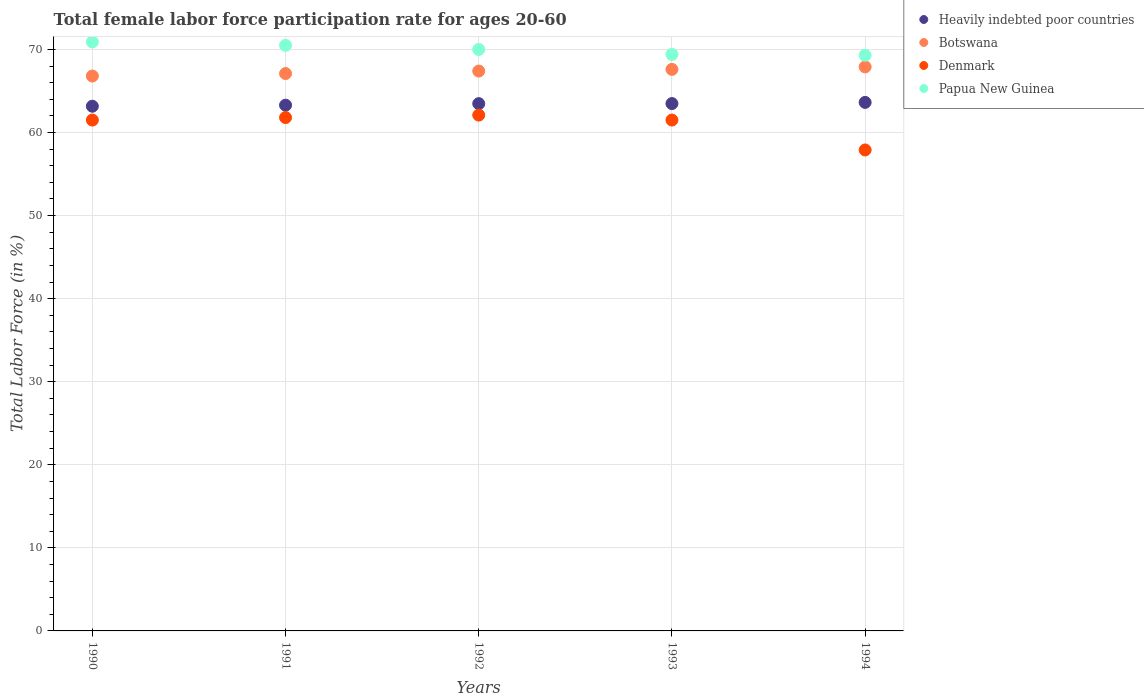How many different coloured dotlines are there?
Provide a succinct answer. 4. What is the female labor force participation rate in Denmark in 1993?
Your response must be concise. 61.5. Across all years, what is the maximum female labor force participation rate in Heavily indebted poor countries?
Provide a short and direct response. 63.63. Across all years, what is the minimum female labor force participation rate in Botswana?
Offer a terse response. 66.8. What is the total female labor force participation rate in Denmark in the graph?
Your answer should be compact. 304.8. What is the difference between the female labor force participation rate in Heavily indebted poor countries in 1990 and that in 1991?
Ensure brevity in your answer.  -0.13. What is the difference between the female labor force participation rate in Papua New Guinea in 1992 and the female labor force participation rate in Botswana in 1990?
Your answer should be very brief. 3.2. What is the average female labor force participation rate in Heavily indebted poor countries per year?
Make the answer very short. 63.41. In the year 1991, what is the difference between the female labor force participation rate in Heavily indebted poor countries and female labor force participation rate in Denmark?
Keep it short and to the point. 1.49. In how many years, is the female labor force participation rate in Papua New Guinea greater than 60 %?
Your answer should be very brief. 5. What is the ratio of the female labor force participation rate in Heavily indebted poor countries in 1990 to that in 1992?
Give a very brief answer. 1. Is the female labor force participation rate in Denmark in 1990 less than that in 1991?
Your answer should be compact. Yes. Is the difference between the female labor force participation rate in Heavily indebted poor countries in 1991 and 1994 greater than the difference between the female labor force participation rate in Denmark in 1991 and 1994?
Offer a terse response. No. What is the difference between the highest and the second highest female labor force participation rate in Papua New Guinea?
Provide a short and direct response. 0.4. What is the difference between the highest and the lowest female labor force participation rate in Heavily indebted poor countries?
Offer a very short reply. 0.46. In how many years, is the female labor force participation rate in Botswana greater than the average female labor force participation rate in Botswana taken over all years?
Make the answer very short. 3. Is the sum of the female labor force participation rate in Papua New Guinea in 1993 and 1994 greater than the maximum female labor force participation rate in Heavily indebted poor countries across all years?
Ensure brevity in your answer.  Yes. Is it the case that in every year, the sum of the female labor force participation rate in Botswana and female labor force participation rate in Heavily indebted poor countries  is greater than the sum of female labor force participation rate in Papua New Guinea and female labor force participation rate in Denmark?
Offer a very short reply. Yes. Is it the case that in every year, the sum of the female labor force participation rate in Botswana and female labor force participation rate in Denmark  is greater than the female labor force participation rate in Papua New Guinea?
Offer a very short reply. Yes. Is the female labor force participation rate in Heavily indebted poor countries strictly less than the female labor force participation rate in Botswana over the years?
Your answer should be compact. Yes. How many years are there in the graph?
Keep it short and to the point. 5. What is the difference between two consecutive major ticks on the Y-axis?
Give a very brief answer. 10. Does the graph contain grids?
Offer a terse response. Yes. What is the title of the graph?
Provide a short and direct response. Total female labor force participation rate for ages 20-60. Does "Latin America(all income levels)" appear as one of the legend labels in the graph?
Provide a succinct answer. No. What is the label or title of the X-axis?
Provide a short and direct response. Years. What is the label or title of the Y-axis?
Make the answer very short. Total Labor Force (in %). What is the Total Labor Force (in %) of Heavily indebted poor countries in 1990?
Give a very brief answer. 63.16. What is the Total Labor Force (in %) of Botswana in 1990?
Your response must be concise. 66.8. What is the Total Labor Force (in %) of Denmark in 1990?
Keep it short and to the point. 61.5. What is the Total Labor Force (in %) of Papua New Guinea in 1990?
Provide a succinct answer. 70.9. What is the Total Labor Force (in %) of Heavily indebted poor countries in 1991?
Provide a short and direct response. 63.29. What is the Total Labor Force (in %) of Botswana in 1991?
Give a very brief answer. 67.1. What is the Total Labor Force (in %) in Denmark in 1991?
Provide a short and direct response. 61.8. What is the Total Labor Force (in %) in Papua New Guinea in 1991?
Provide a short and direct response. 70.5. What is the Total Labor Force (in %) in Heavily indebted poor countries in 1992?
Your response must be concise. 63.48. What is the Total Labor Force (in %) in Botswana in 1992?
Keep it short and to the point. 67.4. What is the Total Labor Force (in %) of Denmark in 1992?
Your answer should be compact. 62.1. What is the Total Labor Force (in %) in Papua New Guinea in 1992?
Provide a short and direct response. 70. What is the Total Labor Force (in %) of Heavily indebted poor countries in 1993?
Provide a succinct answer. 63.49. What is the Total Labor Force (in %) of Botswana in 1993?
Keep it short and to the point. 67.6. What is the Total Labor Force (in %) in Denmark in 1993?
Give a very brief answer. 61.5. What is the Total Labor Force (in %) in Papua New Guinea in 1993?
Give a very brief answer. 69.4. What is the Total Labor Force (in %) in Heavily indebted poor countries in 1994?
Keep it short and to the point. 63.63. What is the Total Labor Force (in %) of Botswana in 1994?
Keep it short and to the point. 67.9. What is the Total Labor Force (in %) in Denmark in 1994?
Offer a terse response. 57.9. What is the Total Labor Force (in %) in Papua New Guinea in 1994?
Provide a succinct answer. 69.3. Across all years, what is the maximum Total Labor Force (in %) of Heavily indebted poor countries?
Your answer should be compact. 63.63. Across all years, what is the maximum Total Labor Force (in %) in Botswana?
Keep it short and to the point. 67.9. Across all years, what is the maximum Total Labor Force (in %) of Denmark?
Keep it short and to the point. 62.1. Across all years, what is the maximum Total Labor Force (in %) of Papua New Guinea?
Make the answer very short. 70.9. Across all years, what is the minimum Total Labor Force (in %) of Heavily indebted poor countries?
Ensure brevity in your answer.  63.16. Across all years, what is the minimum Total Labor Force (in %) in Botswana?
Offer a terse response. 66.8. Across all years, what is the minimum Total Labor Force (in %) of Denmark?
Give a very brief answer. 57.9. Across all years, what is the minimum Total Labor Force (in %) of Papua New Guinea?
Keep it short and to the point. 69.3. What is the total Total Labor Force (in %) of Heavily indebted poor countries in the graph?
Give a very brief answer. 317.04. What is the total Total Labor Force (in %) of Botswana in the graph?
Ensure brevity in your answer.  336.8. What is the total Total Labor Force (in %) in Denmark in the graph?
Make the answer very short. 304.8. What is the total Total Labor Force (in %) of Papua New Guinea in the graph?
Make the answer very short. 350.1. What is the difference between the Total Labor Force (in %) of Heavily indebted poor countries in 1990 and that in 1991?
Your answer should be very brief. -0.13. What is the difference between the Total Labor Force (in %) in Denmark in 1990 and that in 1991?
Your answer should be very brief. -0.3. What is the difference between the Total Labor Force (in %) of Heavily indebted poor countries in 1990 and that in 1992?
Offer a terse response. -0.31. What is the difference between the Total Labor Force (in %) in Botswana in 1990 and that in 1992?
Provide a short and direct response. -0.6. What is the difference between the Total Labor Force (in %) of Denmark in 1990 and that in 1992?
Keep it short and to the point. -0.6. What is the difference between the Total Labor Force (in %) of Papua New Guinea in 1990 and that in 1992?
Make the answer very short. 0.9. What is the difference between the Total Labor Force (in %) in Heavily indebted poor countries in 1990 and that in 1993?
Your response must be concise. -0.32. What is the difference between the Total Labor Force (in %) of Papua New Guinea in 1990 and that in 1993?
Keep it short and to the point. 1.5. What is the difference between the Total Labor Force (in %) of Heavily indebted poor countries in 1990 and that in 1994?
Provide a succinct answer. -0.46. What is the difference between the Total Labor Force (in %) of Denmark in 1990 and that in 1994?
Your answer should be very brief. 3.6. What is the difference between the Total Labor Force (in %) in Heavily indebted poor countries in 1991 and that in 1992?
Your response must be concise. -0.19. What is the difference between the Total Labor Force (in %) in Botswana in 1991 and that in 1992?
Provide a short and direct response. -0.3. What is the difference between the Total Labor Force (in %) in Heavily indebted poor countries in 1991 and that in 1993?
Make the answer very short. -0.19. What is the difference between the Total Labor Force (in %) of Botswana in 1991 and that in 1993?
Offer a very short reply. -0.5. What is the difference between the Total Labor Force (in %) in Denmark in 1991 and that in 1993?
Provide a succinct answer. 0.3. What is the difference between the Total Labor Force (in %) of Papua New Guinea in 1991 and that in 1993?
Offer a terse response. 1.1. What is the difference between the Total Labor Force (in %) of Heavily indebted poor countries in 1991 and that in 1994?
Offer a terse response. -0.33. What is the difference between the Total Labor Force (in %) of Botswana in 1991 and that in 1994?
Keep it short and to the point. -0.8. What is the difference between the Total Labor Force (in %) of Denmark in 1991 and that in 1994?
Offer a very short reply. 3.9. What is the difference between the Total Labor Force (in %) of Heavily indebted poor countries in 1992 and that in 1993?
Your answer should be compact. -0.01. What is the difference between the Total Labor Force (in %) of Denmark in 1992 and that in 1993?
Give a very brief answer. 0.6. What is the difference between the Total Labor Force (in %) of Heavily indebted poor countries in 1992 and that in 1994?
Ensure brevity in your answer.  -0.15. What is the difference between the Total Labor Force (in %) in Denmark in 1992 and that in 1994?
Offer a very short reply. 4.2. What is the difference between the Total Labor Force (in %) in Papua New Guinea in 1992 and that in 1994?
Make the answer very short. 0.7. What is the difference between the Total Labor Force (in %) in Heavily indebted poor countries in 1993 and that in 1994?
Give a very brief answer. -0.14. What is the difference between the Total Labor Force (in %) of Botswana in 1993 and that in 1994?
Provide a succinct answer. -0.3. What is the difference between the Total Labor Force (in %) in Papua New Guinea in 1993 and that in 1994?
Provide a short and direct response. 0.1. What is the difference between the Total Labor Force (in %) of Heavily indebted poor countries in 1990 and the Total Labor Force (in %) of Botswana in 1991?
Your answer should be compact. -3.94. What is the difference between the Total Labor Force (in %) in Heavily indebted poor countries in 1990 and the Total Labor Force (in %) in Denmark in 1991?
Offer a very short reply. 1.36. What is the difference between the Total Labor Force (in %) in Heavily indebted poor countries in 1990 and the Total Labor Force (in %) in Papua New Guinea in 1991?
Ensure brevity in your answer.  -7.34. What is the difference between the Total Labor Force (in %) in Botswana in 1990 and the Total Labor Force (in %) in Papua New Guinea in 1991?
Your answer should be compact. -3.7. What is the difference between the Total Labor Force (in %) of Heavily indebted poor countries in 1990 and the Total Labor Force (in %) of Botswana in 1992?
Your answer should be very brief. -4.24. What is the difference between the Total Labor Force (in %) in Heavily indebted poor countries in 1990 and the Total Labor Force (in %) in Denmark in 1992?
Your response must be concise. 1.06. What is the difference between the Total Labor Force (in %) of Heavily indebted poor countries in 1990 and the Total Labor Force (in %) of Papua New Guinea in 1992?
Offer a terse response. -6.84. What is the difference between the Total Labor Force (in %) of Botswana in 1990 and the Total Labor Force (in %) of Denmark in 1992?
Your answer should be compact. 4.7. What is the difference between the Total Labor Force (in %) of Heavily indebted poor countries in 1990 and the Total Labor Force (in %) of Botswana in 1993?
Ensure brevity in your answer.  -4.44. What is the difference between the Total Labor Force (in %) in Heavily indebted poor countries in 1990 and the Total Labor Force (in %) in Denmark in 1993?
Your answer should be compact. 1.66. What is the difference between the Total Labor Force (in %) in Heavily indebted poor countries in 1990 and the Total Labor Force (in %) in Papua New Guinea in 1993?
Provide a short and direct response. -6.24. What is the difference between the Total Labor Force (in %) in Heavily indebted poor countries in 1990 and the Total Labor Force (in %) in Botswana in 1994?
Offer a terse response. -4.74. What is the difference between the Total Labor Force (in %) of Heavily indebted poor countries in 1990 and the Total Labor Force (in %) of Denmark in 1994?
Give a very brief answer. 5.26. What is the difference between the Total Labor Force (in %) of Heavily indebted poor countries in 1990 and the Total Labor Force (in %) of Papua New Guinea in 1994?
Ensure brevity in your answer.  -6.14. What is the difference between the Total Labor Force (in %) in Botswana in 1990 and the Total Labor Force (in %) in Denmark in 1994?
Your answer should be very brief. 8.9. What is the difference between the Total Labor Force (in %) of Heavily indebted poor countries in 1991 and the Total Labor Force (in %) of Botswana in 1992?
Give a very brief answer. -4.11. What is the difference between the Total Labor Force (in %) in Heavily indebted poor countries in 1991 and the Total Labor Force (in %) in Denmark in 1992?
Offer a very short reply. 1.19. What is the difference between the Total Labor Force (in %) of Heavily indebted poor countries in 1991 and the Total Labor Force (in %) of Papua New Guinea in 1992?
Make the answer very short. -6.71. What is the difference between the Total Labor Force (in %) in Denmark in 1991 and the Total Labor Force (in %) in Papua New Guinea in 1992?
Offer a very short reply. -8.2. What is the difference between the Total Labor Force (in %) of Heavily indebted poor countries in 1991 and the Total Labor Force (in %) of Botswana in 1993?
Make the answer very short. -4.31. What is the difference between the Total Labor Force (in %) of Heavily indebted poor countries in 1991 and the Total Labor Force (in %) of Denmark in 1993?
Provide a short and direct response. 1.79. What is the difference between the Total Labor Force (in %) in Heavily indebted poor countries in 1991 and the Total Labor Force (in %) in Papua New Guinea in 1993?
Keep it short and to the point. -6.11. What is the difference between the Total Labor Force (in %) of Botswana in 1991 and the Total Labor Force (in %) of Denmark in 1993?
Provide a succinct answer. 5.6. What is the difference between the Total Labor Force (in %) in Botswana in 1991 and the Total Labor Force (in %) in Papua New Guinea in 1993?
Offer a very short reply. -2.3. What is the difference between the Total Labor Force (in %) of Heavily indebted poor countries in 1991 and the Total Labor Force (in %) of Botswana in 1994?
Make the answer very short. -4.61. What is the difference between the Total Labor Force (in %) in Heavily indebted poor countries in 1991 and the Total Labor Force (in %) in Denmark in 1994?
Offer a very short reply. 5.39. What is the difference between the Total Labor Force (in %) of Heavily indebted poor countries in 1991 and the Total Labor Force (in %) of Papua New Guinea in 1994?
Give a very brief answer. -6.01. What is the difference between the Total Labor Force (in %) of Botswana in 1991 and the Total Labor Force (in %) of Denmark in 1994?
Keep it short and to the point. 9.2. What is the difference between the Total Labor Force (in %) of Botswana in 1991 and the Total Labor Force (in %) of Papua New Guinea in 1994?
Give a very brief answer. -2.2. What is the difference between the Total Labor Force (in %) in Denmark in 1991 and the Total Labor Force (in %) in Papua New Guinea in 1994?
Keep it short and to the point. -7.5. What is the difference between the Total Labor Force (in %) of Heavily indebted poor countries in 1992 and the Total Labor Force (in %) of Botswana in 1993?
Ensure brevity in your answer.  -4.12. What is the difference between the Total Labor Force (in %) of Heavily indebted poor countries in 1992 and the Total Labor Force (in %) of Denmark in 1993?
Your response must be concise. 1.98. What is the difference between the Total Labor Force (in %) of Heavily indebted poor countries in 1992 and the Total Labor Force (in %) of Papua New Guinea in 1993?
Your answer should be compact. -5.92. What is the difference between the Total Labor Force (in %) in Denmark in 1992 and the Total Labor Force (in %) in Papua New Guinea in 1993?
Give a very brief answer. -7.3. What is the difference between the Total Labor Force (in %) in Heavily indebted poor countries in 1992 and the Total Labor Force (in %) in Botswana in 1994?
Offer a very short reply. -4.42. What is the difference between the Total Labor Force (in %) in Heavily indebted poor countries in 1992 and the Total Labor Force (in %) in Denmark in 1994?
Ensure brevity in your answer.  5.58. What is the difference between the Total Labor Force (in %) of Heavily indebted poor countries in 1992 and the Total Labor Force (in %) of Papua New Guinea in 1994?
Offer a terse response. -5.82. What is the difference between the Total Labor Force (in %) of Botswana in 1992 and the Total Labor Force (in %) of Denmark in 1994?
Provide a short and direct response. 9.5. What is the difference between the Total Labor Force (in %) of Botswana in 1992 and the Total Labor Force (in %) of Papua New Guinea in 1994?
Your answer should be compact. -1.9. What is the difference between the Total Labor Force (in %) of Denmark in 1992 and the Total Labor Force (in %) of Papua New Guinea in 1994?
Offer a terse response. -7.2. What is the difference between the Total Labor Force (in %) in Heavily indebted poor countries in 1993 and the Total Labor Force (in %) in Botswana in 1994?
Make the answer very short. -4.41. What is the difference between the Total Labor Force (in %) of Heavily indebted poor countries in 1993 and the Total Labor Force (in %) of Denmark in 1994?
Give a very brief answer. 5.59. What is the difference between the Total Labor Force (in %) of Heavily indebted poor countries in 1993 and the Total Labor Force (in %) of Papua New Guinea in 1994?
Keep it short and to the point. -5.81. What is the average Total Labor Force (in %) of Heavily indebted poor countries per year?
Provide a succinct answer. 63.41. What is the average Total Labor Force (in %) of Botswana per year?
Offer a terse response. 67.36. What is the average Total Labor Force (in %) of Denmark per year?
Offer a very short reply. 60.96. What is the average Total Labor Force (in %) in Papua New Guinea per year?
Provide a short and direct response. 70.02. In the year 1990, what is the difference between the Total Labor Force (in %) in Heavily indebted poor countries and Total Labor Force (in %) in Botswana?
Provide a short and direct response. -3.64. In the year 1990, what is the difference between the Total Labor Force (in %) of Heavily indebted poor countries and Total Labor Force (in %) of Denmark?
Make the answer very short. 1.66. In the year 1990, what is the difference between the Total Labor Force (in %) in Heavily indebted poor countries and Total Labor Force (in %) in Papua New Guinea?
Offer a very short reply. -7.74. In the year 1990, what is the difference between the Total Labor Force (in %) in Denmark and Total Labor Force (in %) in Papua New Guinea?
Provide a succinct answer. -9.4. In the year 1991, what is the difference between the Total Labor Force (in %) of Heavily indebted poor countries and Total Labor Force (in %) of Botswana?
Keep it short and to the point. -3.81. In the year 1991, what is the difference between the Total Labor Force (in %) of Heavily indebted poor countries and Total Labor Force (in %) of Denmark?
Offer a very short reply. 1.49. In the year 1991, what is the difference between the Total Labor Force (in %) in Heavily indebted poor countries and Total Labor Force (in %) in Papua New Guinea?
Ensure brevity in your answer.  -7.21. In the year 1991, what is the difference between the Total Labor Force (in %) of Botswana and Total Labor Force (in %) of Denmark?
Provide a succinct answer. 5.3. In the year 1991, what is the difference between the Total Labor Force (in %) in Denmark and Total Labor Force (in %) in Papua New Guinea?
Give a very brief answer. -8.7. In the year 1992, what is the difference between the Total Labor Force (in %) of Heavily indebted poor countries and Total Labor Force (in %) of Botswana?
Keep it short and to the point. -3.92. In the year 1992, what is the difference between the Total Labor Force (in %) of Heavily indebted poor countries and Total Labor Force (in %) of Denmark?
Ensure brevity in your answer.  1.38. In the year 1992, what is the difference between the Total Labor Force (in %) in Heavily indebted poor countries and Total Labor Force (in %) in Papua New Guinea?
Your answer should be very brief. -6.52. In the year 1992, what is the difference between the Total Labor Force (in %) in Botswana and Total Labor Force (in %) in Denmark?
Your response must be concise. 5.3. In the year 1992, what is the difference between the Total Labor Force (in %) in Botswana and Total Labor Force (in %) in Papua New Guinea?
Provide a succinct answer. -2.6. In the year 1992, what is the difference between the Total Labor Force (in %) in Denmark and Total Labor Force (in %) in Papua New Guinea?
Give a very brief answer. -7.9. In the year 1993, what is the difference between the Total Labor Force (in %) of Heavily indebted poor countries and Total Labor Force (in %) of Botswana?
Give a very brief answer. -4.11. In the year 1993, what is the difference between the Total Labor Force (in %) in Heavily indebted poor countries and Total Labor Force (in %) in Denmark?
Give a very brief answer. 1.99. In the year 1993, what is the difference between the Total Labor Force (in %) in Heavily indebted poor countries and Total Labor Force (in %) in Papua New Guinea?
Give a very brief answer. -5.91. In the year 1994, what is the difference between the Total Labor Force (in %) of Heavily indebted poor countries and Total Labor Force (in %) of Botswana?
Offer a terse response. -4.27. In the year 1994, what is the difference between the Total Labor Force (in %) in Heavily indebted poor countries and Total Labor Force (in %) in Denmark?
Provide a succinct answer. 5.73. In the year 1994, what is the difference between the Total Labor Force (in %) in Heavily indebted poor countries and Total Labor Force (in %) in Papua New Guinea?
Your answer should be very brief. -5.67. In the year 1994, what is the difference between the Total Labor Force (in %) in Botswana and Total Labor Force (in %) in Papua New Guinea?
Make the answer very short. -1.4. In the year 1994, what is the difference between the Total Labor Force (in %) of Denmark and Total Labor Force (in %) of Papua New Guinea?
Provide a succinct answer. -11.4. What is the ratio of the Total Labor Force (in %) of Heavily indebted poor countries in 1990 to that in 1991?
Offer a very short reply. 1. What is the ratio of the Total Labor Force (in %) of Heavily indebted poor countries in 1990 to that in 1992?
Provide a short and direct response. 1. What is the ratio of the Total Labor Force (in %) in Botswana in 1990 to that in 1992?
Keep it short and to the point. 0.99. What is the ratio of the Total Labor Force (in %) in Denmark in 1990 to that in 1992?
Your answer should be compact. 0.99. What is the ratio of the Total Labor Force (in %) in Papua New Guinea in 1990 to that in 1992?
Offer a very short reply. 1.01. What is the ratio of the Total Labor Force (in %) in Heavily indebted poor countries in 1990 to that in 1993?
Offer a terse response. 0.99. What is the ratio of the Total Labor Force (in %) in Botswana in 1990 to that in 1993?
Offer a terse response. 0.99. What is the ratio of the Total Labor Force (in %) of Papua New Guinea in 1990 to that in 1993?
Keep it short and to the point. 1.02. What is the ratio of the Total Labor Force (in %) of Heavily indebted poor countries in 1990 to that in 1994?
Your answer should be compact. 0.99. What is the ratio of the Total Labor Force (in %) of Botswana in 1990 to that in 1994?
Your response must be concise. 0.98. What is the ratio of the Total Labor Force (in %) of Denmark in 1990 to that in 1994?
Provide a short and direct response. 1.06. What is the ratio of the Total Labor Force (in %) of Papua New Guinea in 1990 to that in 1994?
Make the answer very short. 1.02. What is the ratio of the Total Labor Force (in %) in Heavily indebted poor countries in 1991 to that in 1992?
Your answer should be compact. 1. What is the ratio of the Total Labor Force (in %) of Denmark in 1991 to that in 1992?
Offer a terse response. 1. What is the ratio of the Total Labor Force (in %) of Papua New Guinea in 1991 to that in 1992?
Ensure brevity in your answer.  1.01. What is the ratio of the Total Labor Force (in %) of Heavily indebted poor countries in 1991 to that in 1993?
Offer a very short reply. 1. What is the ratio of the Total Labor Force (in %) in Papua New Guinea in 1991 to that in 1993?
Your answer should be very brief. 1.02. What is the ratio of the Total Labor Force (in %) of Botswana in 1991 to that in 1994?
Offer a terse response. 0.99. What is the ratio of the Total Labor Force (in %) in Denmark in 1991 to that in 1994?
Provide a short and direct response. 1.07. What is the ratio of the Total Labor Force (in %) of Papua New Guinea in 1991 to that in 1994?
Provide a short and direct response. 1.02. What is the ratio of the Total Labor Force (in %) in Heavily indebted poor countries in 1992 to that in 1993?
Your answer should be compact. 1. What is the ratio of the Total Labor Force (in %) in Botswana in 1992 to that in 1993?
Keep it short and to the point. 1. What is the ratio of the Total Labor Force (in %) in Denmark in 1992 to that in 1993?
Provide a succinct answer. 1.01. What is the ratio of the Total Labor Force (in %) in Papua New Guinea in 1992 to that in 1993?
Offer a very short reply. 1.01. What is the ratio of the Total Labor Force (in %) in Heavily indebted poor countries in 1992 to that in 1994?
Give a very brief answer. 1. What is the ratio of the Total Labor Force (in %) of Botswana in 1992 to that in 1994?
Offer a terse response. 0.99. What is the ratio of the Total Labor Force (in %) of Denmark in 1992 to that in 1994?
Ensure brevity in your answer.  1.07. What is the ratio of the Total Labor Force (in %) of Papua New Guinea in 1992 to that in 1994?
Offer a very short reply. 1.01. What is the ratio of the Total Labor Force (in %) in Heavily indebted poor countries in 1993 to that in 1994?
Provide a succinct answer. 1. What is the ratio of the Total Labor Force (in %) in Botswana in 1993 to that in 1994?
Give a very brief answer. 1. What is the ratio of the Total Labor Force (in %) of Denmark in 1993 to that in 1994?
Your answer should be very brief. 1.06. What is the ratio of the Total Labor Force (in %) in Papua New Guinea in 1993 to that in 1994?
Offer a very short reply. 1. What is the difference between the highest and the second highest Total Labor Force (in %) of Heavily indebted poor countries?
Ensure brevity in your answer.  0.14. What is the difference between the highest and the second highest Total Labor Force (in %) of Botswana?
Give a very brief answer. 0.3. What is the difference between the highest and the lowest Total Labor Force (in %) of Heavily indebted poor countries?
Offer a very short reply. 0.46. What is the difference between the highest and the lowest Total Labor Force (in %) in Botswana?
Provide a succinct answer. 1.1. 